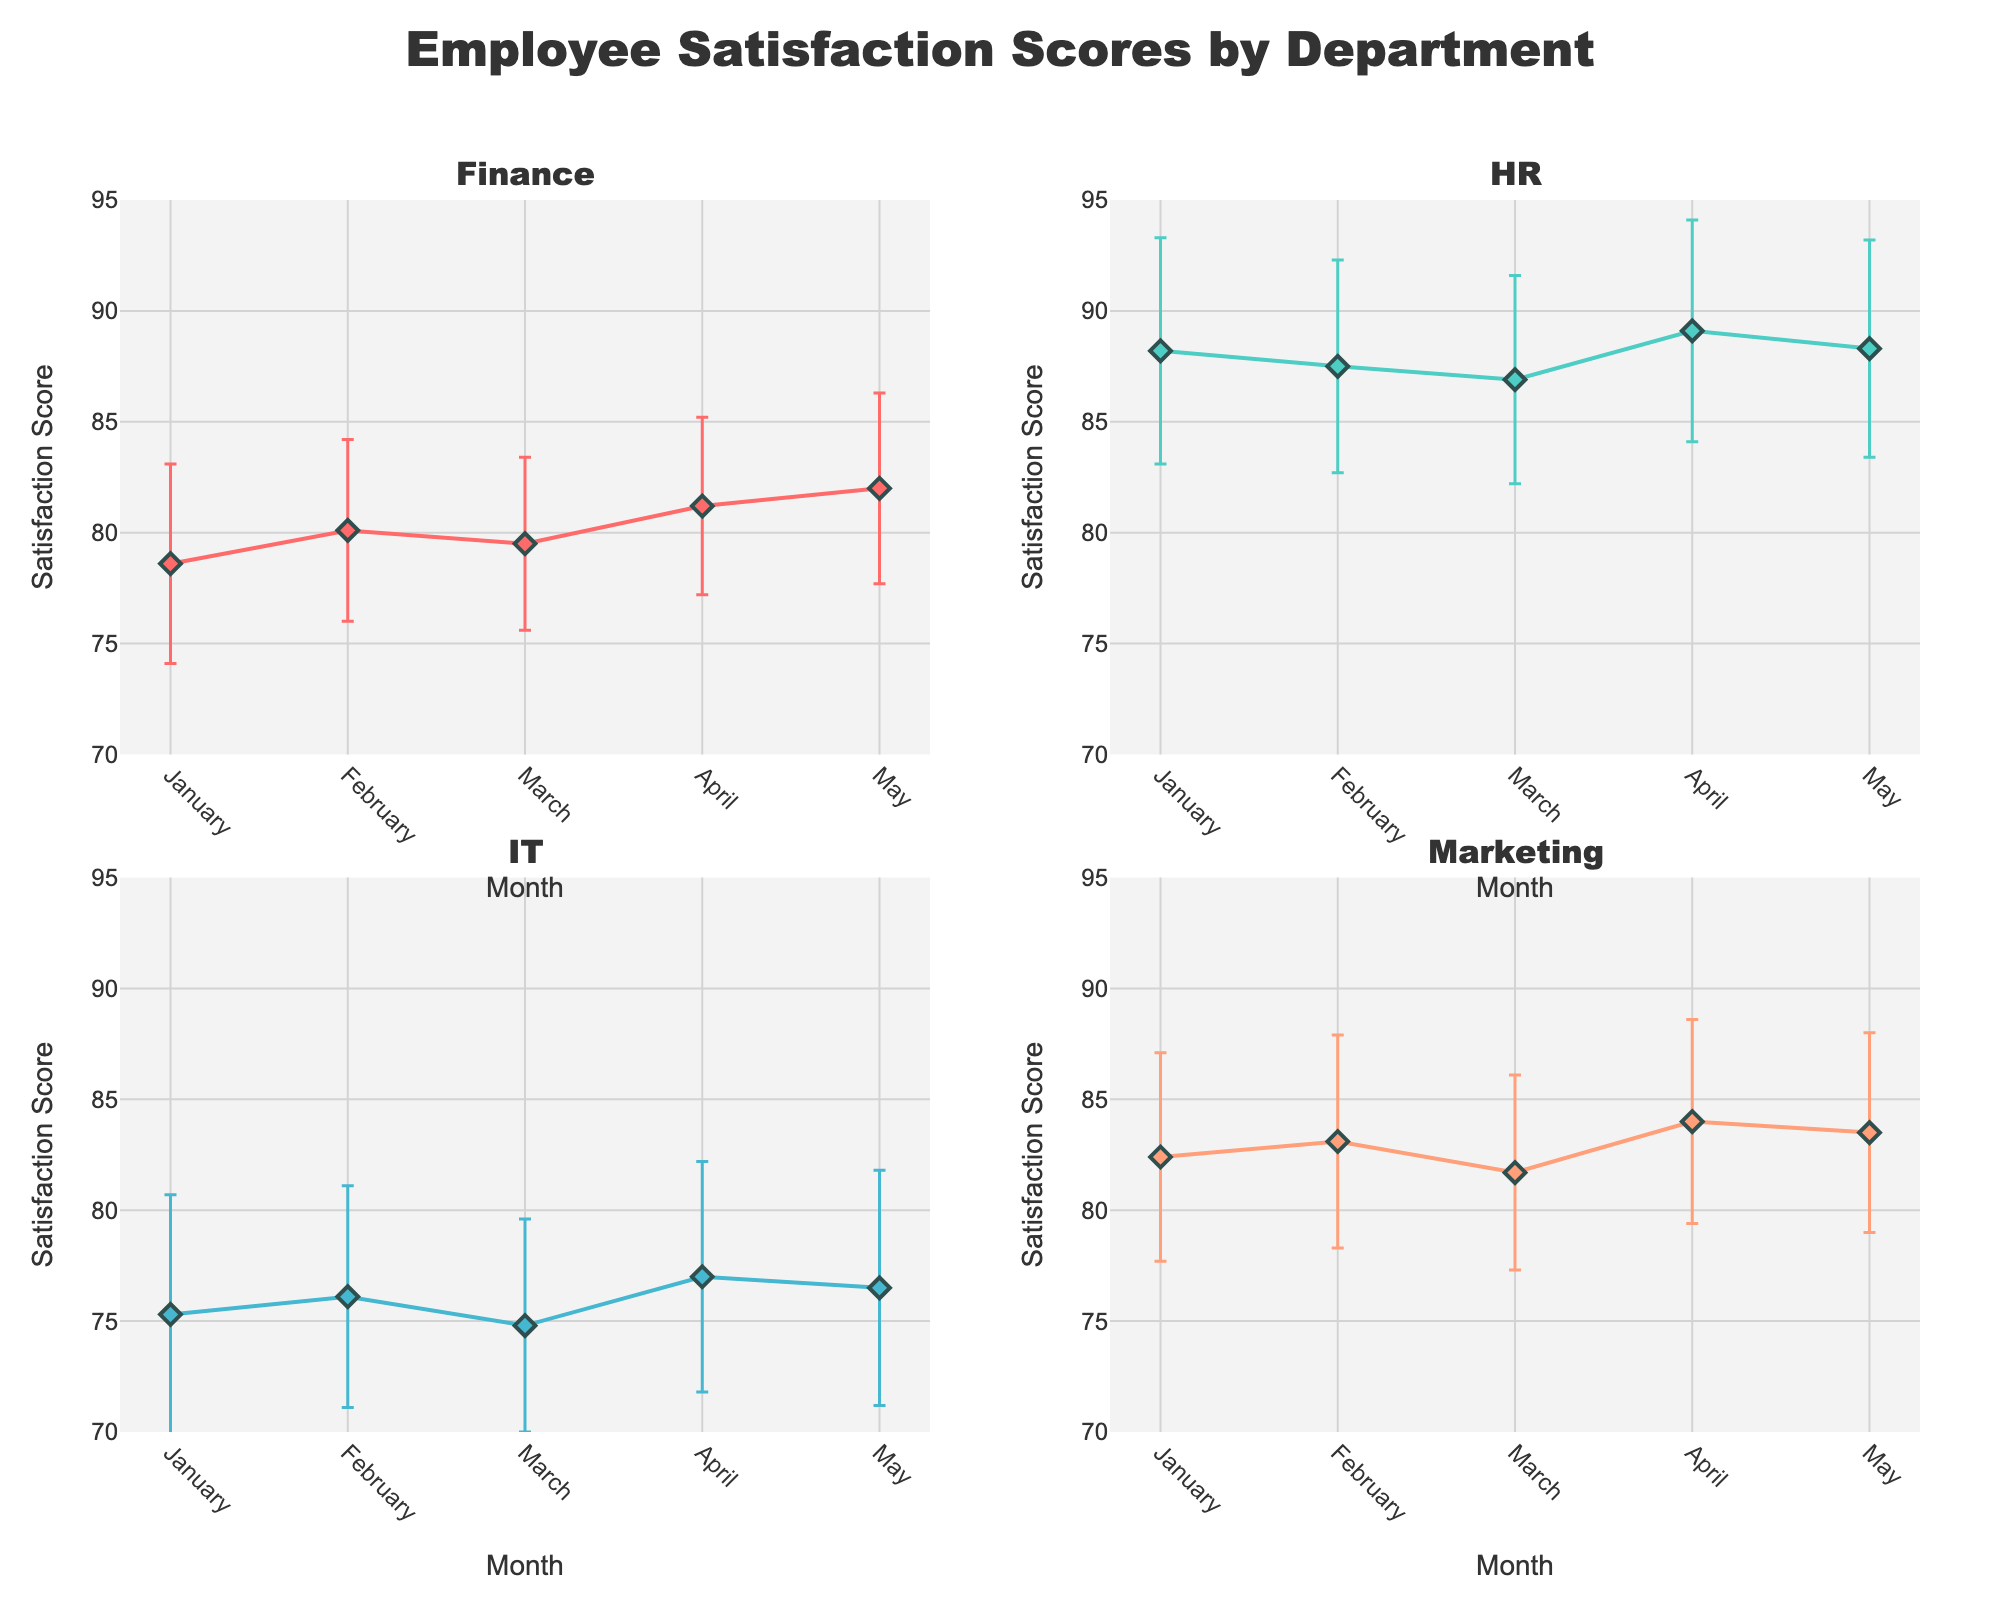What is the title of the figure? The title is displayed at the top center of the figure. It reads "Employee Satisfaction Scores by Department".
Answer: Employee Satisfaction Scores by Department Which department has the highest employee satisfaction score for January? By looking at the subplots, the HR department has the highest satisfaction score in January compared to Finance, IT, and Marketing. The HR satisfaction score for January is 88.2.
Answer: HR Which department has the lowest average satisfaction score across all months? To answer this, we need to average the monthly scores for each department. IT's scores are consistently lower across all months compared to other departments. Calculating the averages: Finance: (78.6+80.1+79.5+81.2+82.0)/5 = 80.28; HR: (88.2+87.5+86.9+89.1+88.3)/5 = 88.0; IT: (75.3+76.1+74.8+77.0+76.5)/5 = 75.94; Marketing: (82.4+83.1+81.7+84.0+83.5)/5 = 82.94. IT has the lowest average score.
Answer: IT In which month did the Finance department experience the highest employee satisfaction score? The Finance subplot shows the highest satisfaction score is in May with a score of 82.0.
Answer: May What is the range of employee satisfaction scores for the HR department in April? The satisfaction score for HR in April is 89.1. The standard deviation is 5.0. The range considering one standard deviation is 89.1 ± 5.0, which is 84.1 to 94.1.
Answer: 84.1 to 94.1 How do the satisfaction score trends compare between the Finance and Marketing departments? Comparing the subplots, both Finance and Marketing show an increase in satisfaction scores from January to May. However, Marketing starts at a higher score and consistently remains above Finance.
Answer: Both increase, but Marketing remains higher Which month shows the highest variation in employee satisfaction scores for the IT department? The IT subplot shows error bars representing standard deviations. The widest error bar is in January, with a standard deviation of 5.4, indicating the highest variation.
Answer: January Between February and March, did the HR department's satisfaction score increase or decrease, and by how much? According to the HR subplot, the satisfaction score decreased from 87.5 in February to 86.9 in March. The change is 87.5 - 86.9 = 0.6.
Answer: Decrease by 0.6 Comparing March, which department has a lower employee satisfaction score, IT or Marketing? By looking at the subplots for March, IT has a satisfaction score of 74.8 while Marketing has a score of 81.7. IT has the lower score.
Answer: IT Is there any month where Marketing's satisfaction score decreased compared to the previous month? By scrutinizing the Marketing subplot, from February (83.1) to March (81.7), there is a decrease in the satisfaction score.
Answer: Yes, between February and March 